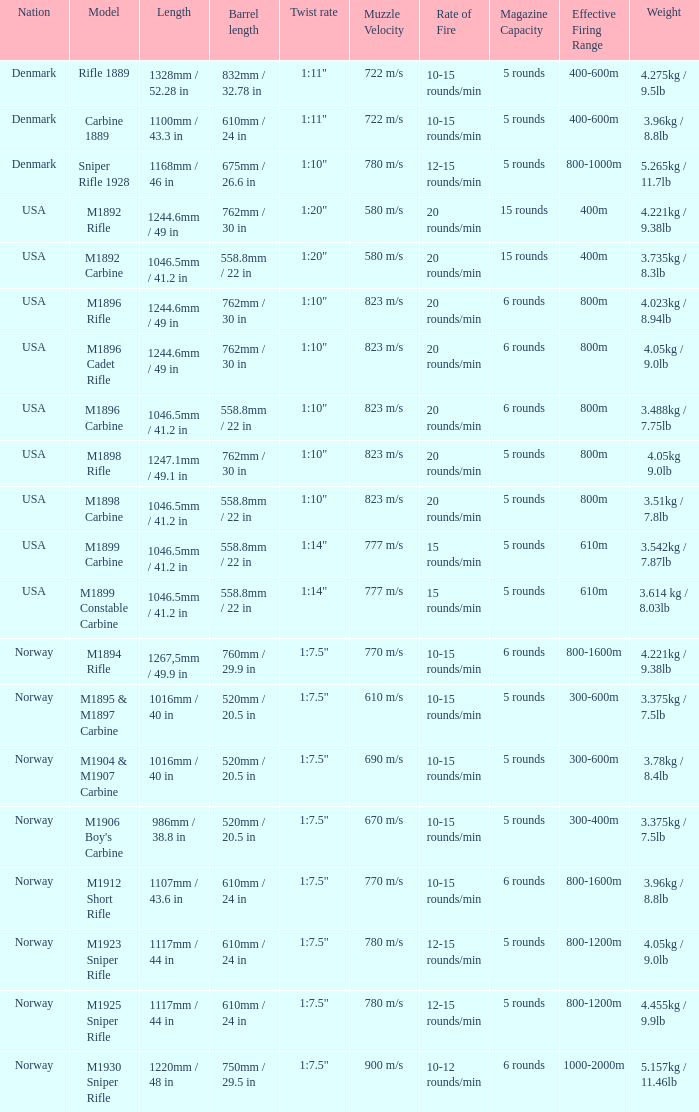What is Nation, when Model is M1895 & M1897 Carbine? Norway. 